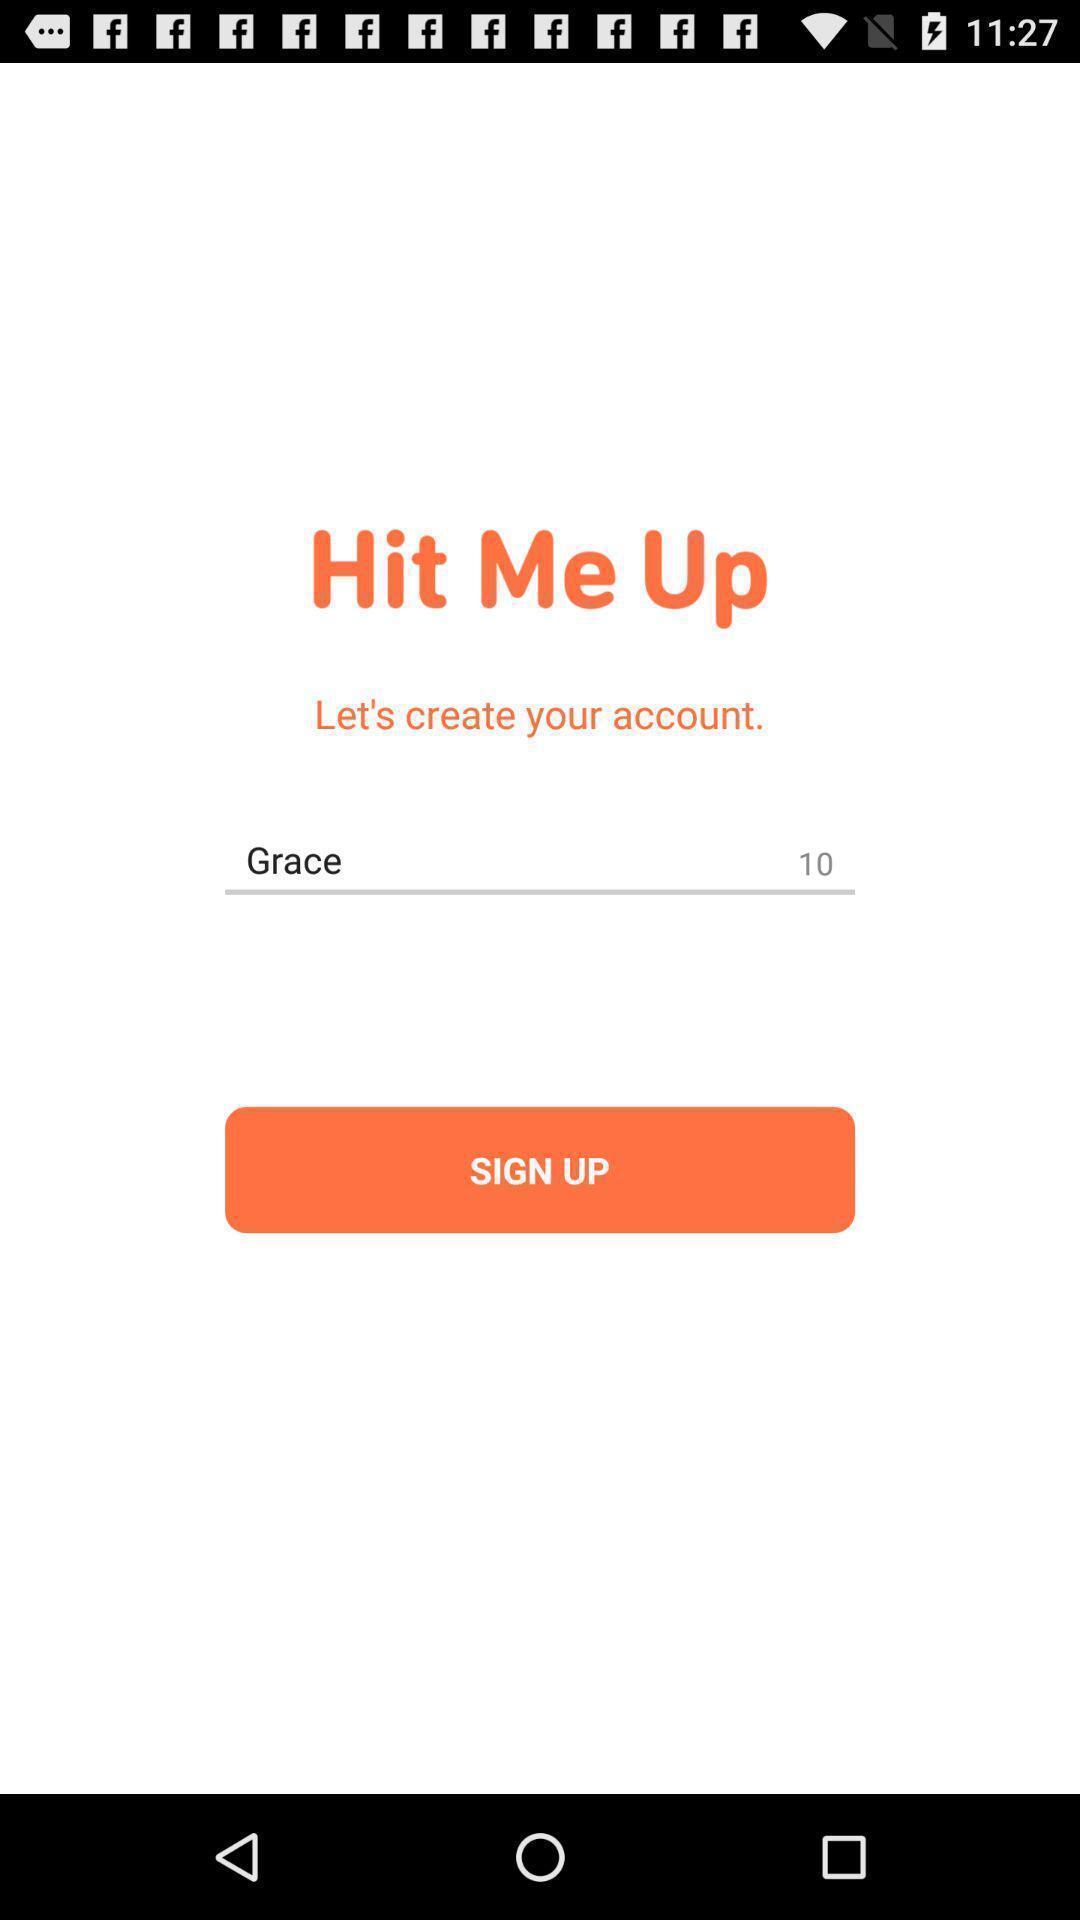Describe the visual elements of this screenshot. Sign up page. 